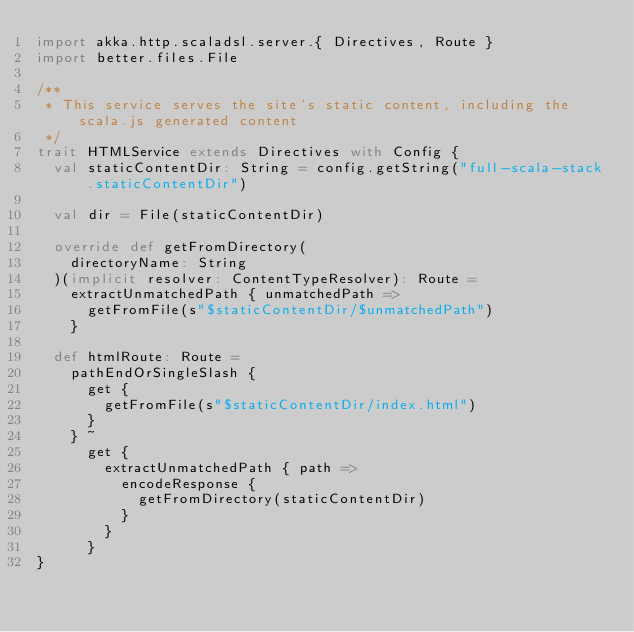<code> <loc_0><loc_0><loc_500><loc_500><_Scala_>import akka.http.scaladsl.server.{ Directives, Route }
import better.files.File

/**
 * This service serves the site's static content, including the scala.js generated content
 */
trait HTMLService extends Directives with Config {
  val staticContentDir: String = config.getString("full-scala-stack.staticContentDir")

  val dir = File(staticContentDir)

  override def getFromDirectory(
    directoryName: String
  )(implicit resolver: ContentTypeResolver): Route =
    extractUnmatchedPath { unmatchedPath =>
      getFromFile(s"$staticContentDir/$unmatchedPath")
    }

  def htmlRoute: Route =
    pathEndOrSingleSlash {
      get {
        getFromFile(s"$staticContentDir/index.html")
      }
    } ~
      get {
        extractUnmatchedPath { path =>
          encodeResponse {
            getFromDirectory(staticContentDir)
          }
        }
      }
}
</code> 